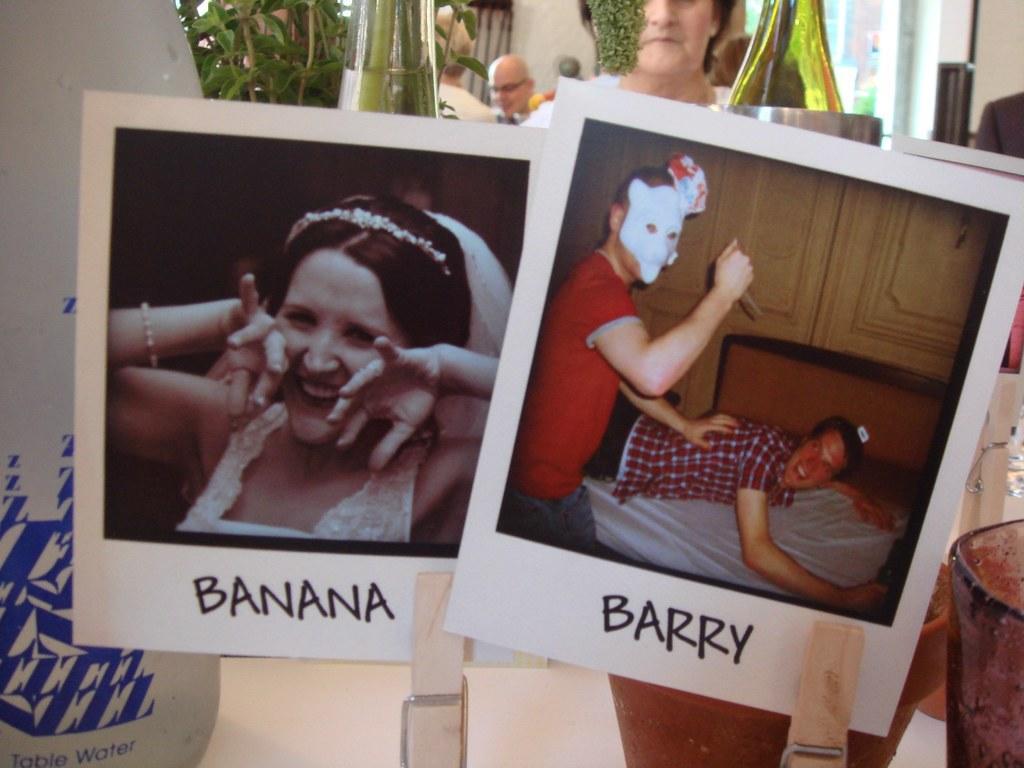How would you summarize this image in a sentence or two? In this image in the front there are posters with some text and images on it. In the background there are persons there are bottles, leaves and there is a wall. In the center there are pots. 